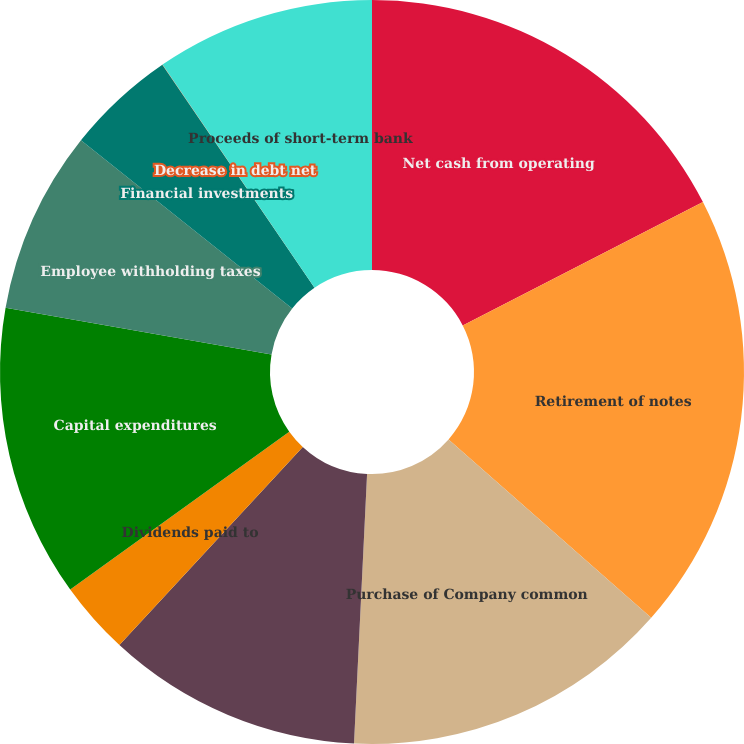Convert chart to OTSL. <chart><loc_0><loc_0><loc_500><loc_500><pie_chart><fcel>Net cash from operating<fcel>Retirement of notes<fcel>Purchase of Company common<fcel>Cash dividends paid<fcel>Dividends paid to<fcel>Capital expenditures<fcel>Employee withholding taxes<fcel>Financial investments<fcel>Decrease in debt net<fcel>Proceeds of short-term bank<nl><fcel>17.45%<fcel>19.04%<fcel>14.28%<fcel>11.11%<fcel>3.18%<fcel>12.7%<fcel>7.94%<fcel>4.77%<fcel>0.01%<fcel>9.52%<nl></chart> 